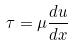<formula> <loc_0><loc_0><loc_500><loc_500>\tau = \mu \frac { d u } { d x }</formula> 